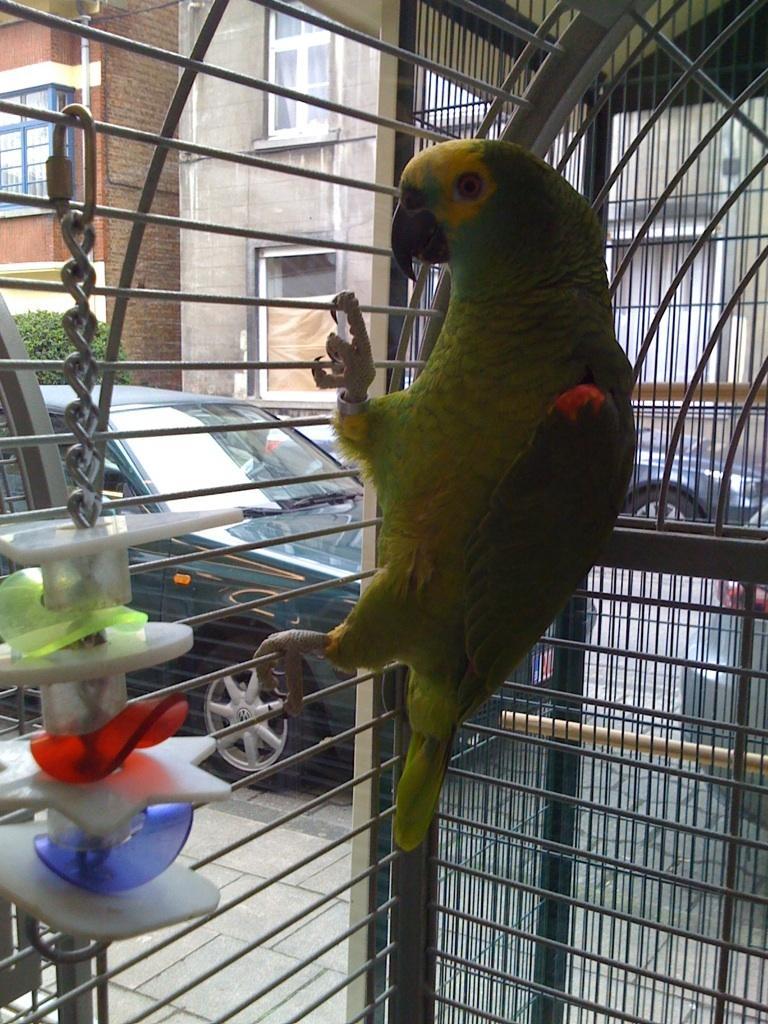Can you describe this image briefly? In the picture I can see a parrot in the cage. Here I can see some objects in the cage. In the background I can see vehicles, buildings, plants and some other objects. 